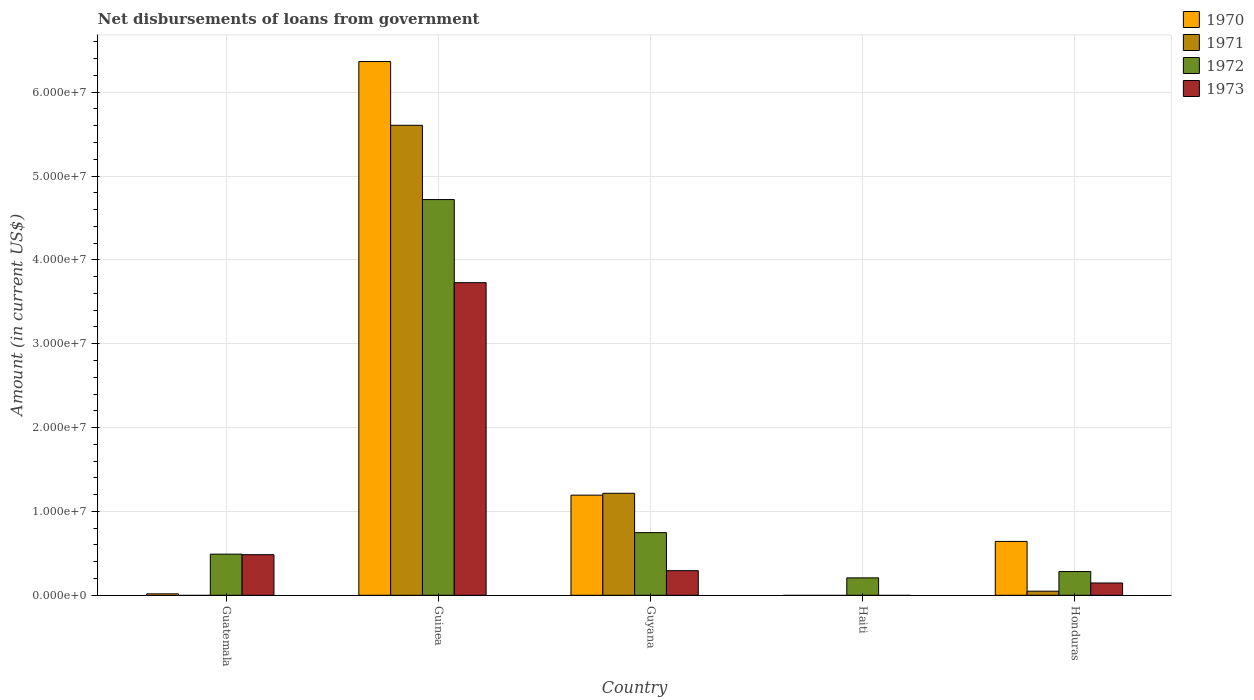Are the number of bars per tick equal to the number of legend labels?
Provide a succinct answer. No. How many bars are there on the 4th tick from the left?
Provide a succinct answer. 1. How many bars are there on the 4th tick from the right?
Offer a terse response. 4. What is the label of the 3rd group of bars from the left?
Your answer should be very brief. Guyana. What is the amount of loan disbursed from government in 1973 in Guinea?
Make the answer very short. 3.73e+07. Across all countries, what is the maximum amount of loan disbursed from government in 1973?
Keep it short and to the point. 3.73e+07. Across all countries, what is the minimum amount of loan disbursed from government in 1971?
Ensure brevity in your answer.  0. In which country was the amount of loan disbursed from government in 1970 maximum?
Your response must be concise. Guinea. What is the total amount of loan disbursed from government in 1971 in the graph?
Provide a succinct answer. 6.87e+07. What is the difference between the amount of loan disbursed from government in 1970 in Guyana and that in Honduras?
Provide a succinct answer. 5.52e+06. What is the difference between the amount of loan disbursed from government in 1970 in Honduras and the amount of loan disbursed from government in 1971 in Guyana?
Ensure brevity in your answer.  -5.74e+06. What is the average amount of loan disbursed from government in 1972 per country?
Your response must be concise. 1.29e+07. What is the difference between the amount of loan disbursed from government of/in 1973 and amount of loan disbursed from government of/in 1970 in Guatemala?
Provide a short and direct response. 4.67e+06. In how many countries, is the amount of loan disbursed from government in 1971 greater than 62000000 US$?
Give a very brief answer. 0. What is the ratio of the amount of loan disbursed from government in 1970 in Guinea to that in Honduras?
Offer a terse response. 9.91. What is the difference between the highest and the second highest amount of loan disbursed from government in 1973?
Keep it short and to the point. 3.24e+07. What is the difference between the highest and the lowest amount of loan disbursed from government in 1971?
Provide a short and direct response. 5.60e+07. In how many countries, is the amount of loan disbursed from government in 1971 greater than the average amount of loan disbursed from government in 1971 taken over all countries?
Provide a succinct answer. 1. Is the sum of the amount of loan disbursed from government in 1973 in Guatemala and Guyana greater than the maximum amount of loan disbursed from government in 1972 across all countries?
Keep it short and to the point. No. Are all the bars in the graph horizontal?
Keep it short and to the point. No. How many countries are there in the graph?
Provide a short and direct response. 5. What is the difference between two consecutive major ticks on the Y-axis?
Offer a very short reply. 1.00e+07. Does the graph contain any zero values?
Offer a terse response. Yes. Does the graph contain grids?
Keep it short and to the point. Yes. How many legend labels are there?
Offer a terse response. 4. How are the legend labels stacked?
Your answer should be very brief. Vertical. What is the title of the graph?
Your answer should be very brief. Net disbursements of loans from government. What is the Amount (in current US$) of 1970 in Guatemala?
Give a very brief answer. 1.70e+05. What is the Amount (in current US$) of 1971 in Guatemala?
Your answer should be very brief. 0. What is the Amount (in current US$) of 1972 in Guatemala?
Make the answer very short. 4.90e+06. What is the Amount (in current US$) of 1973 in Guatemala?
Your answer should be compact. 4.84e+06. What is the Amount (in current US$) of 1970 in Guinea?
Give a very brief answer. 6.36e+07. What is the Amount (in current US$) of 1971 in Guinea?
Your answer should be very brief. 5.60e+07. What is the Amount (in current US$) in 1972 in Guinea?
Ensure brevity in your answer.  4.72e+07. What is the Amount (in current US$) of 1973 in Guinea?
Make the answer very short. 3.73e+07. What is the Amount (in current US$) of 1970 in Guyana?
Offer a very short reply. 1.19e+07. What is the Amount (in current US$) in 1971 in Guyana?
Ensure brevity in your answer.  1.22e+07. What is the Amount (in current US$) of 1972 in Guyana?
Your answer should be compact. 7.47e+06. What is the Amount (in current US$) in 1973 in Guyana?
Keep it short and to the point. 2.94e+06. What is the Amount (in current US$) in 1970 in Haiti?
Your response must be concise. 0. What is the Amount (in current US$) of 1971 in Haiti?
Provide a succinct answer. 0. What is the Amount (in current US$) in 1972 in Haiti?
Your response must be concise. 2.08e+06. What is the Amount (in current US$) in 1973 in Haiti?
Provide a succinct answer. 0. What is the Amount (in current US$) of 1970 in Honduras?
Your answer should be very brief. 6.42e+06. What is the Amount (in current US$) of 1971 in Honduras?
Your answer should be very brief. 4.87e+05. What is the Amount (in current US$) of 1972 in Honduras?
Provide a short and direct response. 2.83e+06. What is the Amount (in current US$) of 1973 in Honduras?
Provide a succinct answer. 1.46e+06. Across all countries, what is the maximum Amount (in current US$) in 1970?
Your answer should be very brief. 6.36e+07. Across all countries, what is the maximum Amount (in current US$) in 1971?
Your answer should be compact. 5.60e+07. Across all countries, what is the maximum Amount (in current US$) of 1972?
Your response must be concise. 4.72e+07. Across all countries, what is the maximum Amount (in current US$) of 1973?
Give a very brief answer. 3.73e+07. Across all countries, what is the minimum Amount (in current US$) in 1972?
Your response must be concise. 2.08e+06. What is the total Amount (in current US$) in 1970 in the graph?
Keep it short and to the point. 8.22e+07. What is the total Amount (in current US$) in 1971 in the graph?
Your answer should be very brief. 6.87e+07. What is the total Amount (in current US$) of 1972 in the graph?
Ensure brevity in your answer.  6.45e+07. What is the total Amount (in current US$) of 1973 in the graph?
Make the answer very short. 4.65e+07. What is the difference between the Amount (in current US$) of 1970 in Guatemala and that in Guinea?
Offer a terse response. -6.35e+07. What is the difference between the Amount (in current US$) in 1972 in Guatemala and that in Guinea?
Give a very brief answer. -4.23e+07. What is the difference between the Amount (in current US$) in 1973 in Guatemala and that in Guinea?
Your response must be concise. -3.24e+07. What is the difference between the Amount (in current US$) of 1970 in Guatemala and that in Guyana?
Provide a succinct answer. -1.18e+07. What is the difference between the Amount (in current US$) of 1972 in Guatemala and that in Guyana?
Give a very brief answer. -2.57e+06. What is the difference between the Amount (in current US$) in 1973 in Guatemala and that in Guyana?
Your answer should be very brief. 1.91e+06. What is the difference between the Amount (in current US$) of 1972 in Guatemala and that in Haiti?
Provide a short and direct response. 2.83e+06. What is the difference between the Amount (in current US$) of 1970 in Guatemala and that in Honduras?
Offer a terse response. -6.25e+06. What is the difference between the Amount (in current US$) in 1972 in Guatemala and that in Honduras?
Keep it short and to the point. 2.07e+06. What is the difference between the Amount (in current US$) in 1973 in Guatemala and that in Honduras?
Give a very brief answer. 3.38e+06. What is the difference between the Amount (in current US$) in 1970 in Guinea and that in Guyana?
Provide a short and direct response. 5.17e+07. What is the difference between the Amount (in current US$) in 1971 in Guinea and that in Guyana?
Give a very brief answer. 4.39e+07. What is the difference between the Amount (in current US$) of 1972 in Guinea and that in Guyana?
Offer a terse response. 3.97e+07. What is the difference between the Amount (in current US$) in 1973 in Guinea and that in Guyana?
Your response must be concise. 3.43e+07. What is the difference between the Amount (in current US$) in 1972 in Guinea and that in Haiti?
Your answer should be very brief. 4.51e+07. What is the difference between the Amount (in current US$) of 1970 in Guinea and that in Honduras?
Offer a terse response. 5.72e+07. What is the difference between the Amount (in current US$) of 1971 in Guinea and that in Honduras?
Offer a terse response. 5.56e+07. What is the difference between the Amount (in current US$) in 1972 in Guinea and that in Honduras?
Make the answer very short. 4.44e+07. What is the difference between the Amount (in current US$) in 1973 in Guinea and that in Honduras?
Your response must be concise. 3.58e+07. What is the difference between the Amount (in current US$) of 1972 in Guyana and that in Haiti?
Provide a succinct answer. 5.40e+06. What is the difference between the Amount (in current US$) in 1970 in Guyana and that in Honduras?
Your answer should be very brief. 5.52e+06. What is the difference between the Amount (in current US$) of 1971 in Guyana and that in Honduras?
Ensure brevity in your answer.  1.17e+07. What is the difference between the Amount (in current US$) in 1972 in Guyana and that in Honduras?
Your answer should be compact. 4.64e+06. What is the difference between the Amount (in current US$) in 1973 in Guyana and that in Honduras?
Your answer should be compact. 1.47e+06. What is the difference between the Amount (in current US$) in 1972 in Haiti and that in Honduras?
Ensure brevity in your answer.  -7.55e+05. What is the difference between the Amount (in current US$) of 1970 in Guatemala and the Amount (in current US$) of 1971 in Guinea?
Give a very brief answer. -5.59e+07. What is the difference between the Amount (in current US$) in 1970 in Guatemala and the Amount (in current US$) in 1972 in Guinea?
Your answer should be very brief. -4.70e+07. What is the difference between the Amount (in current US$) of 1970 in Guatemala and the Amount (in current US$) of 1973 in Guinea?
Your response must be concise. -3.71e+07. What is the difference between the Amount (in current US$) of 1972 in Guatemala and the Amount (in current US$) of 1973 in Guinea?
Provide a succinct answer. -3.24e+07. What is the difference between the Amount (in current US$) of 1970 in Guatemala and the Amount (in current US$) of 1971 in Guyana?
Make the answer very short. -1.20e+07. What is the difference between the Amount (in current US$) in 1970 in Guatemala and the Amount (in current US$) in 1972 in Guyana?
Give a very brief answer. -7.30e+06. What is the difference between the Amount (in current US$) in 1970 in Guatemala and the Amount (in current US$) in 1973 in Guyana?
Ensure brevity in your answer.  -2.76e+06. What is the difference between the Amount (in current US$) in 1972 in Guatemala and the Amount (in current US$) in 1973 in Guyana?
Your response must be concise. 1.97e+06. What is the difference between the Amount (in current US$) in 1970 in Guatemala and the Amount (in current US$) in 1972 in Haiti?
Offer a terse response. -1.91e+06. What is the difference between the Amount (in current US$) in 1970 in Guatemala and the Amount (in current US$) in 1971 in Honduras?
Offer a terse response. -3.17e+05. What is the difference between the Amount (in current US$) in 1970 in Guatemala and the Amount (in current US$) in 1972 in Honduras?
Offer a very short reply. -2.66e+06. What is the difference between the Amount (in current US$) of 1970 in Guatemala and the Amount (in current US$) of 1973 in Honduras?
Provide a short and direct response. -1.29e+06. What is the difference between the Amount (in current US$) in 1972 in Guatemala and the Amount (in current US$) in 1973 in Honduras?
Your answer should be very brief. 3.44e+06. What is the difference between the Amount (in current US$) of 1970 in Guinea and the Amount (in current US$) of 1971 in Guyana?
Your answer should be compact. 5.15e+07. What is the difference between the Amount (in current US$) in 1970 in Guinea and the Amount (in current US$) in 1972 in Guyana?
Keep it short and to the point. 5.62e+07. What is the difference between the Amount (in current US$) in 1970 in Guinea and the Amount (in current US$) in 1973 in Guyana?
Offer a terse response. 6.07e+07. What is the difference between the Amount (in current US$) in 1971 in Guinea and the Amount (in current US$) in 1972 in Guyana?
Give a very brief answer. 4.86e+07. What is the difference between the Amount (in current US$) in 1971 in Guinea and the Amount (in current US$) in 1973 in Guyana?
Keep it short and to the point. 5.31e+07. What is the difference between the Amount (in current US$) of 1972 in Guinea and the Amount (in current US$) of 1973 in Guyana?
Give a very brief answer. 4.43e+07. What is the difference between the Amount (in current US$) in 1970 in Guinea and the Amount (in current US$) in 1972 in Haiti?
Provide a succinct answer. 6.16e+07. What is the difference between the Amount (in current US$) in 1971 in Guinea and the Amount (in current US$) in 1972 in Haiti?
Keep it short and to the point. 5.40e+07. What is the difference between the Amount (in current US$) in 1970 in Guinea and the Amount (in current US$) in 1971 in Honduras?
Your answer should be very brief. 6.32e+07. What is the difference between the Amount (in current US$) of 1970 in Guinea and the Amount (in current US$) of 1972 in Honduras?
Ensure brevity in your answer.  6.08e+07. What is the difference between the Amount (in current US$) of 1970 in Guinea and the Amount (in current US$) of 1973 in Honduras?
Give a very brief answer. 6.22e+07. What is the difference between the Amount (in current US$) of 1971 in Guinea and the Amount (in current US$) of 1972 in Honduras?
Your answer should be very brief. 5.32e+07. What is the difference between the Amount (in current US$) in 1971 in Guinea and the Amount (in current US$) in 1973 in Honduras?
Ensure brevity in your answer.  5.46e+07. What is the difference between the Amount (in current US$) of 1972 in Guinea and the Amount (in current US$) of 1973 in Honduras?
Your answer should be compact. 4.57e+07. What is the difference between the Amount (in current US$) of 1970 in Guyana and the Amount (in current US$) of 1972 in Haiti?
Offer a terse response. 9.86e+06. What is the difference between the Amount (in current US$) in 1971 in Guyana and the Amount (in current US$) in 1972 in Haiti?
Ensure brevity in your answer.  1.01e+07. What is the difference between the Amount (in current US$) of 1970 in Guyana and the Amount (in current US$) of 1971 in Honduras?
Ensure brevity in your answer.  1.15e+07. What is the difference between the Amount (in current US$) of 1970 in Guyana and the Amount (in current US$) of 1972 in Honduras?
Make the answer very short. 9.11e+06. What is the difference between the Amount (in current US$) in 1970 in Guyana and the Amount (in current US$) in 1973 in Honduras?
Make the answer very short. 1.05e+07. What is the difference between the Amount (in current US$) of 1971 in Guyana and the Amount (in current US$) of 1972 in Honduras?
Keep it short and to the point. 9.33e+06. What is the difference between the Amount (in current US$) of 1971 in Guyana and the Amount (in current US$) of 1973 in Honduras?
Offer a very short reply. 1.07e+07. What is the difference between the Amount (in current US$) of 1972 in Guyana and the Amount (in current US$) of 1973 in Honduras?
Give a very brief answer. 6.01e+06. What is the difference between the Amount (in current US$) in 1972 in Haiti and the Amount (in current US$) in 1973 in Honduras?
Provide a succinct answer. 6.12e+05. What is the average Amount (in current US$) in 1970 per country?
Your response must be concise. 1.64e+07. What is the average Amount (in current US$) in 1971 per country?
Your answer should be compact. 1.37e+07. What is the average Amount (in current US$) of 1972 per country?
Offer a terse response. 1.29e+07. What is the average Amount (in current US$) of 1973 per country?
Provide a succinct answer. 9.30e+06. What is the difference between the Amount (in current US$) in 1970 and Amount (in current US$) in 1972 in Guatemala?
Provide a succinct answer. -4.73e+06. What is the difference between the Amount (in current US$) in 1970 and Amount (in current US$) in 1973 in Guatemala?
Provide a short and direct response. -4.67e+06. What is the difference between the Amount (in current US$) in 1972 and Amount (in current US$) in 1973 in Guatemala?
Your response must be concise. 6.20e+04. What is the difference between the Amount (in current US$) of 1970 and Amount (in current US$) of 1971 in Guinea?
Your answer should be compact. 7.60e+06. What is the difference between the Amount (in current US$) of 1970 and Amount (in current US$) of 1972 in Guinea?
Give a very brief answer. 1.65e+07. What is the difference between the Amount (in current US$) of 1970 and Amount (in current US$) of 1973 in Guinea?
Offer a very short reply. 2.64e+07. What is the difference between the Amount (in current US$) in 1971 and Amount (in current US$) in 1972 in Guinea?
Your response must be concise. 8.86e+06. What is the difference between the Amount (in current US$) in 1971 and Amount (in current US$) in 1973 in Guinea?
Make the answer very short. 1.88e+07. What is the difference between the Amount (in current US$) in 1972 and Amount (in current US$) in 1973 in Guinea?
Your response must be concise. 9.91e+06. What is the difference between the Amount (in current US$) of 1970 and Amount (in current US$) of 1971 in Guyana?
Your answer should be compact. -2.22e+05. What is the difference between the Amount (in current US$) in 1970 and Amount (in current US$) in 1972 in Guyana?
Make the answer very short. 4.47e+06. What is the difference between the Amount (in current US$) in 1970 and Amount (in current US$) in 1973 in Guyana?
Provide a succinct answer. 9.00e+06. What is the difference between the Amount (in current US$) in 1971 and Amount (in current US$) in 1972 in Guyana?
Make the answer very short. 4.69e+06. What is the difference between the Amount (in current US$) in 1971 and Amount (in current US$) in 1973 in Guyana?
Your answer should be compact. 9.23e+06. What is the difference between the Amount (in current US$) of 1972 and Amount (in current US$) of 1973 in Guyana?
Your answer should be very brief. 4.54e+06. What is the difference between the Amount (in current US$) of 1970 and Amount (in current US$) of 1971 in Honduras?
Keep it short and to the point. 5.94e+06. What is the difference between the Amount (in current US$) in 1970 and Amount (in current US$) in 1972 in Honduras?
Your response must be concise. 3.59e+06. What is the difference between the Amount (in current US$) of 1970 and Amount (in current US$) of 1973 in Honduras?
Your answer should be compact. 4.96e+06. What is the difference between the Amount (in current US$) of 1971 and Amount (in current US$) of 1972 in Honduras?
Provide a short and direct response. -2.34e+06. What is the difference between the Amount (in current US$) of 1971 and Amount (in current US$) of 1973 in Honduras?
Keep it short and to the point. -9.77e+05. What is the difference between the Amount (in current US$) of 1972 and Amount (in current US$) of 1973 in Honduras?
Your answer should be compact. 1.37e+06. What is the ratio of the Amount (in current US$) in 1970 in Guatemala to that in Guinea?
Your answer should be very brief. 0. What is the ratio of the Amount (in current US$) of 1972 in Guatemala to that in Guinea?
Offer a very short reply. 0.1. What is the ratio of the Amount (in current US$) in 1973 in Guatemala to that in Guinea?
Provide a short and direct response. 0.13. What is the ratio of the Amount (in current US$) in 1970 in Guatemala to that in Guyana?
Your answer should be compact. 0.01. What is the ratio of the Amount (in current US$) of 1972 in Guatemala to that in Guyana?
Provide a succinct answer. 0.66. What is the ratio of the Amount (in current US$) of 1973 in Guatemala to that in Guyana?
Your response must be concise. 1.65. What is the ratio of the Amount (in current US$) in 1972 in Guatemala to that in Haiti?
Ensure brevity in your answer.  2.36. What is the ratio of the Amount (in current US$) of 1970 in Guatemala to that in Honduras?
Keep it short and to the point. 0.03. What is the ratio of the Amount (in current US$) of 1972 in Guatemala to that in Honduras?
Keep it short and to the point. 1.73. What is the ratio of the Amount (in current US$) of 1973 in Guatemala to that in Honduras?
Provide a succinct answer. 3.31. What is the ratio of the Amount (in current US$) in 1970 in Guinea to that in Guyana?
Give a very brief answer. 5.33. What is the ratio of the Amount (in current US$) of 1971 in Guinea to that in Guyana?
Give a very brief answer. 4.61. What is the ratio of the Amount (in current US$) in 1972 in Guinea to that in Guyana?
Your answer should be compact. 6.32. What is the ratio of the Amount (in current US$) of 1973 in Guinea to that in Guyana?
Provide a short and direct response. 12.7. What is the ratio of the Amount (in current US$) in 1972 in Guinea to that in Haiti?
Your answer should be compact. 22.73. What is the ratio of the Amount (in current US$) in 1970 in Guinea to that in Honduras?
Keep it short and to the point. 9.91. What is the ratio of the Amount (in current US$) of 1971 in Guinea to that in Honduras?
Make the answer very short. 115.09. What is the ratio of the Amount (in current US$) in 1972 in Guinea to that in Honduras?
Give a very brief answer. 16.67. What is the ratio of the Amount (in current US$) of 1973 in Guinea to that in Honduras?
Offer a very short reply. 25.47. What is the ratio of the Amount (in current US$) in 1972 in Guyana to that in Haiti?
Your answer should be very brief. 3.6. What is the ratio of the Amount (in current US$) of 1970 in Guyana to that in Honduras?
Offer a very short reply. 1.86. What is the ratio of the Amount (in current US$) of 1971 in Guyana to that in Honduras?
Ensure brevity in your answer.  24.97. What is the ratio of the Amount (in current US$) in 1972 in Guyana to that in Honduras?
Offer a very short reply. 2.64. What is the ratio of the Amount (in current US$) of 1973 in Guyana to that in Honduras?
Provide a short and direct response. 2. What is the ratio of the Amount (in current US$) of 1972 in Haiti to that in Honduras?
Provide a short and direct response. 0.73. What is the difference between the highest and the second highest Amount (in current US$) of 1970?
Provide a succinct answer. 5.17e+07. What is the difference between the highest and the second highest Amount (in current US$) in 1971?
Keep it short and to the point. 4.39e+07. What is the difference between the highest and the second highest Amount (in current US$) of 1972?
Offer a terse response. 3.97e+07. What is the difference between the highest and the second highest Amount (in current US$) of 1973?
Your answer should be very brief. 3.24e+07. What is the difference between the highest and the lowest Amount (in current US$) of 1970?
Provide a succinct answer. 6.36e+07. What is the difference between the highest and the lowest Amount (in current US$) in 1971?
Your answer should be compact. 5.60e+07. What is the difference between the highest and the lowest Amount (in current US$) of 1972?
Offer a very short reply. 4.51e+07. What is the difference between the highest and the lowest Amount (in current US$) of 1973?
Offer a very short reply. 3.73e+07. 